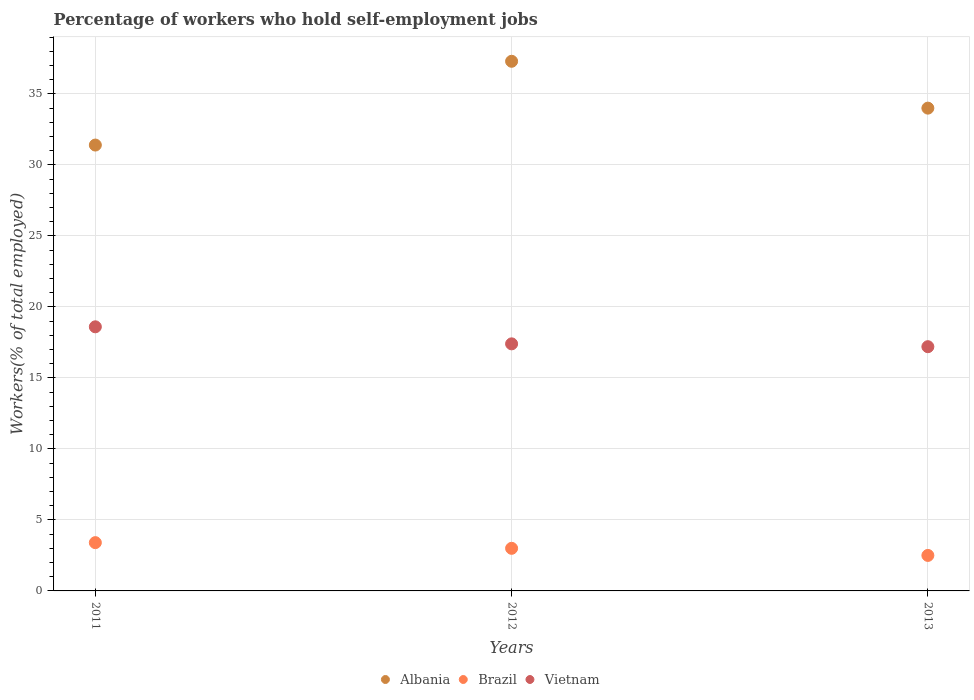What is the percentage of self-employed workers in Albania in 2011?
Your answer should be very brief. 31.4. Across all years, what is the maximum percentage of self-employed workers in Albania?
Give a very brief answer. 37.3. Across all years, what is the minimum percentage of self-employed workers in Vietnam?
Your response must be concise. 17.2. In which year was the percentage of self-employed workers in Vietnam maximum?
Provide a succinct answer. 2011. What is the total percentage of self-employed workers in Albania in the graph?
Keep it short and to the point. 102.7. What is the difference between the percentage of self-employed workers in Brazil in 2011 and that in 2013?
Offer a very short reply. 0.9. What is the difference between the percentage of self-employed workers in Brazil in 2011 and the percentage of self-employed workers in Vietnam in 2012?
Your answer should be compact. -14. What is the average percentage of self-employed workers in Albania per year?
Your answer should be very brief. 34.23. In the year 2012, what is the difference between the percentage of self-employed workers in Brazil and percentage of self-employed workers in Albania?
Ensure brevity in your answer.  -34.3. What is the ratio of the percentage of self-employed workers in Albania in 2012 to that in 2013?
Your answer should be very brief. 1.1. Is the difference between the percentage of self-employed workers in Brazil in 2011 and 2012 greater than the difference between the percentage of self-employed workers in Albania in 2011 and 2012?
Your response must be concise. Yes. What is the difference between the highest and the second highest percentage of self-employed workers in Vietnam?
Your answer should be compact. 1.2. What is the difference between the highest and the lowest percentage of self-employed workers in Albania?
Give a very brief answer. 5.9. Is it the case that in every year, the sum of the percentage of self-employed workers in Vietnam and percentage of self-employed workers in Albania  is greater than the percentage of self-employed workers in Brazil?
Ensure brevity in your answer.  Yes. What is the difference between two consecutive major ticks on the Y-axis?
Your answer should be very brief. 5. Are the values on the major ticks of Y-axis written in scientific E-notation?
Your response must be concise. No. Does the graph contain grids?
Your answer should be compact. Yes. Where does the legend appear in the graph?
Your answer should be very brief. Bottom center. How are the legend labels stacked?
Your response must be concise. Horizontal. What is the title of the graph?
Offer a very short reply. Percentage of workers who hold self-employment jobs. What is the label or title of the Y-axis?
Provide a short and direct response. Workers(% of total employed). What is the Workers(% of total employed) in Albania in 2011?
Your answer should be compact. 31.4. What is the Workers(% of total employed) of Brazil in 2011?
Provide a short and direct response. 3.4. What is the Workers(% of total employed) of Vietnam in 2011?
Provide a succinct answer. 18.6. What is the Workers(% of total employed) of Albania in 2012?
Your response must be concise. 37.3. What is the Workers(% of total employed) in Vietnam in 2012?
Give a very brief answer. 17.4. What is the Workers(% of total employed) in Brazil in 2013?
Provide a succinct answer. 2.5. What is the Workers(% of total employed) in Vietnam in 2013?
Provide a succinct answer. 17.2. Across all years, what is the maximum Workers(% of total employed) of Albania?
Provide a succinct answer. 37.3. Across all years, what is the maximum Workers(% of total employed) in Brazil?
Give a very brief answer. 3.4. Across all years, what is the maximum Workers(% of total employed) of Vietnam?
Offer a very short reply. 18.6. Across all years, what is the minimum Workers(% of total employed) of Albania?
Ensure brevity in your answer.  31.4. Across all years, what is the minimum Workers(% of total employed) in Vietnam?
Give a very brief answer. 17.2. What is the total Workers(% of total employed) in Albania in the graph?
Make the answer very short. 102.7. What is the total Workers(% of total employed) of Brazil in the graph?
Your answer should be very brief. 8.9. What is the total Workers(% of total employed) of Vietnam in the graph?
Your answer should be very brief. 53.2. What is the difference between the Workers(% of total employed) of Albania in 2011 and that in 2012?
Your answer should be compact. -5.9. What is the difference between the Workers(% of total employed) in Brazil in 2011 and that in 2012?
Your answer should be very brief. 0.4. What is the difference between the Workers(% of total employed) in Vietnam in 2011 and that in 2012?
Offer a terse response. 1.2. What is the difference between the Workers(% of total employed) of Albania in 2011 and that in 2013?
Your response must be concise. -2.6. What is the difference between the Workers(% of total employed) in Brazil in 2011 and that in 2013?
Give a very brief answer. 0.9. What is the difference between the Workers(% of total employed) of Vietnam in 2011 and that in 2013?
Provide a succinct answer. 1.4. What is the difference between the Workers(% of total employed) of Brazil in 2012 and that in 2013?
Keep it short and to the point. 0.5. What is the difference between the Workers(% of total employed) in Albania in 2011 and the Workers(% of total employed) in Brazil in 2012?
Your response must be concise. 28.4. What is the difference between the Workers(% of total employed) of Brazil in 2011 and the Workers(% of total employed) of Vietnam in 2012?
Your answer should be compact. -14. What is the difference between the Workers(% of total employed) of Albania in 2011 and the Workers(% of total employed) of Brazil in 2013?
Give a very brief answer. 28.9. What is the difference between the Workers(% of total employed) in Albania in 2012 and the Workers(% of total employed) in Brazil in 2013?
Keep it short and to the point. 34.8. What is the difference between the Workers(% of total employed) of Albania in 2012 and the Workers(% of total employed) of Vietnam in 2013?
Give a very brief answer. 20.1. What is the average Workers(% of total employed) in Albania per year?
Ensure brevity in your answer.  34.23. What is the average Workers(% of total employed) in Brazil per year?
Your response must be concise. 2.97. What is the average Workers(% of total employed) in Vietnam per year?
Your response must be concise. 17.73. In the year 2011, what is the difference between the Workers(% of total employed) in Albania and Workers(% of total employed) in Brazil?
Give a very brief answer. 28. In the year 2011, what is the difference between the Workers(% of total employed) in Brazil and Workers(% of total employed) in Vietnam?
Keep it short and to the point. -15.2. In the year 2012, what is the difference between the Workers(% of total employed) in Albania and Workers(% of total employed) in Brazil?
Keep it short and to the point. 34.3. In the year 2012, what is the difference between the Workers(% of total employed) of Albania and Workers(% of total employed) of Vietnam?
Your answer should be very brief. 19.9. In the year 2012, what is the difference between the Workers(% of total employed) in Brazil and Workers(% of total employed) in Vietnam?
Your answer should be compact. -14.4. In the year 2013, what is the difference between the Workers(% of total employed) in Albania and Workers(% of total employed) in Brazil?
Ensure brevity in your answer.  31.5. In the year 2013, what is the difference between the Workers(% of total employed) in Albania and Workers(% of total employed) in Vietnam?
Give a very brief answer. 16.8. In the year 2013, what is the difference between the Workers(% of total employed) in Brazil and Workers(% of total employed) in Vietnam?
Your answer should be very brief. -14.7. What is the ratio of the Workers(% of total employed) in Albania in 2011 to that in 2012?
Give a very brief answer. 0.84. What is the ratio of the Workers(% of total employed) in Brazil in 2011 to that in 2012?
Offer a terse response. 1.13. What is the ratio of the Workers(% of total employed) in Vietnam in 2011 to that in 2012?
Provide a succinct answer. 1.07. What is the ratio of the Workers(% of total employed) of Albania in 2011 to that in 2013?
Give a very brief answer. 0.92. What is the ratio of the Workers(% of total employed) of Brazil in 2011 to that in 2013?
Keep it short and to the point. 1.36. What is the ratio of the Workers(% of total employed) of Vietnam in 2011 to that in 2013?
Keep it short and to the point. 1.08. What is the ratio of the Workers(% of total employed) in Albania in 2012 to that in 2013?
Offer a terse response. 1.1. What is the ratio of the Workers(% of total employed) in Vietnam in 2012 to that in 2013?
Keep it short and to the point. 1.01. What is the difference between the highest and the second highest Workers(% of total employed) of Brazil?
Keep it short and to the point. 0.4. What is the difference between the highest and the lowest Workers(% of total employed) in Albania?
Your response must be concise. 5.9. What is the difference between the highest and the lowest Workers(% of total employed) in Vietnam?
Give a very brief answer. 1.4. 